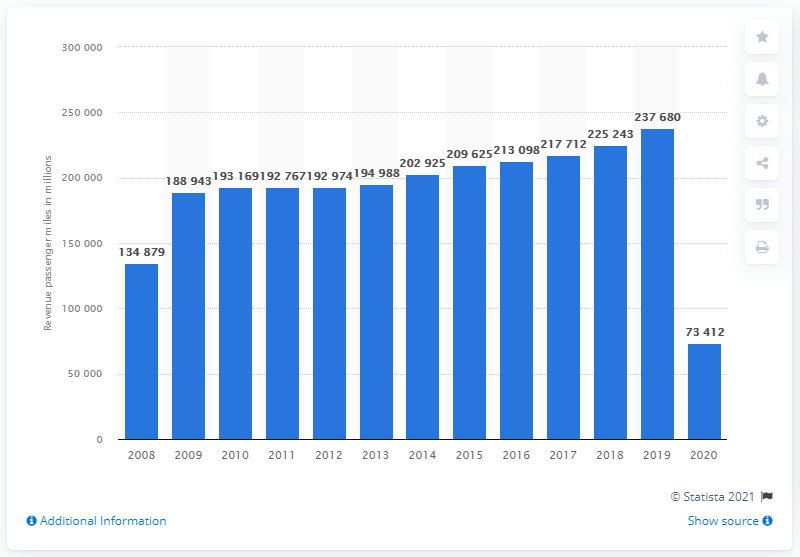Draw attention to some important aspects in this diagram. Delta Air Lines' revenue passenger miles in 2020 were 73,412. 